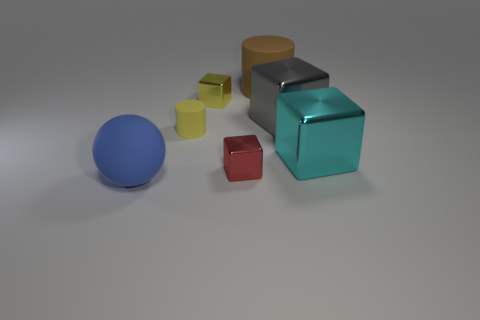Add 3 blue matte things. How many objects exist? 10 Subtract 0 brown blocks. How many objects are left? 7 Subtract all spheres. How many objects are left? 6 Subtract all blocks. Subtract all tiny red metal cubes. How many objects are left? 2 Add 2 yellow cubes. How many yellow cubes are left? 3 Add 1 red things. How many red things exist? 2 